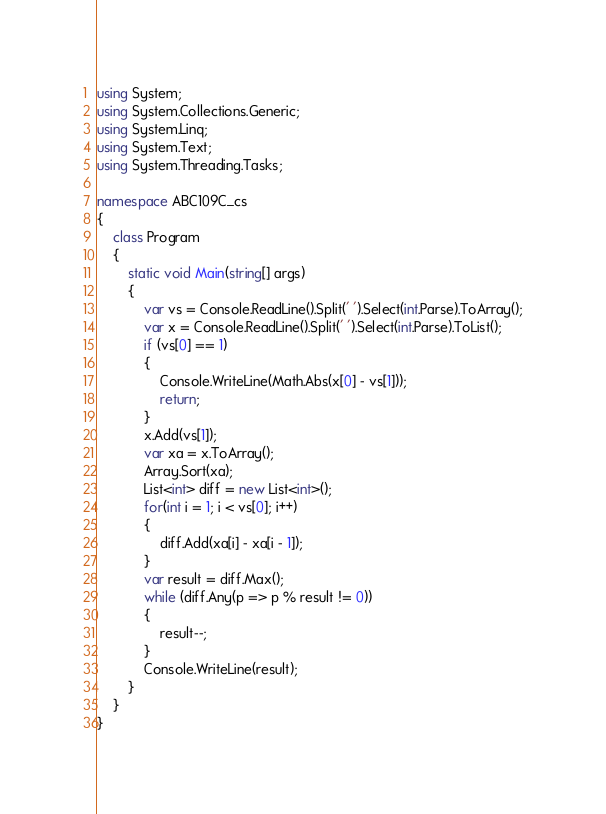Convert code to text. <code><loc_0><loc_0><loc_500><loc_500><_C#_>using System;
using System.Collections.Generic;
using System.Linq;
using System.Text;
using System.Threading.Tasks;

namespace ABC109C_cs
{
    class Program
    {
        static void Main(string[] args)
        {
            var vs = Console.ReadLine().Split(' ').Select(int.Parse).ToArray();
            var x = Console.ReadLine().Split(' ').Select(int.Parse).ToList();
            if (vs[0] == 1)
            {
                Console.WriteLine(Math.Abs(x[0] - vs[1]));
                return;
            }
            x.Add(vs[1]);
            var xa = x.ToArray();
            Array.Sort(xa);
            List<int> diff = new List<int>();
            for(int i = 1; i < vs[0]; i++)
            {
                diff.Add(xa[i] - xa[i - 1]);
            }
            var result = diff.Max();
            while (diff.Any(p => p % result != 0))
            {
                result--;
            }
            Console.WriteLine(result);
        }
    }
}
</code> 